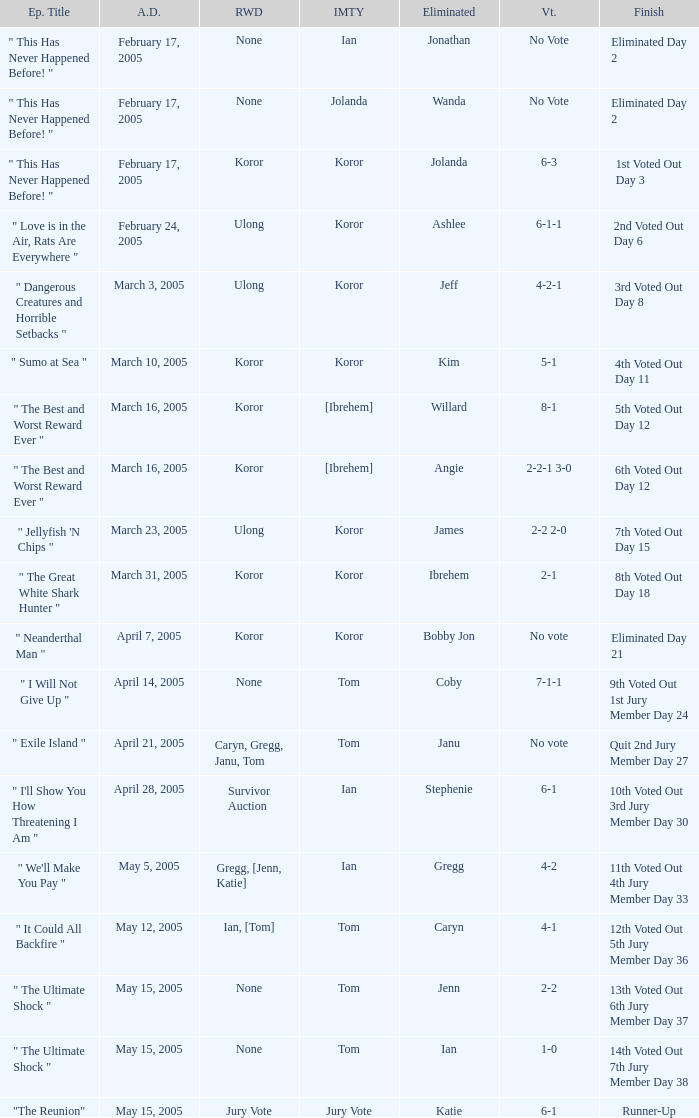What was the vote on the episode where the finish was "10th voted out 3rd jury member day 30"? 6-1. 